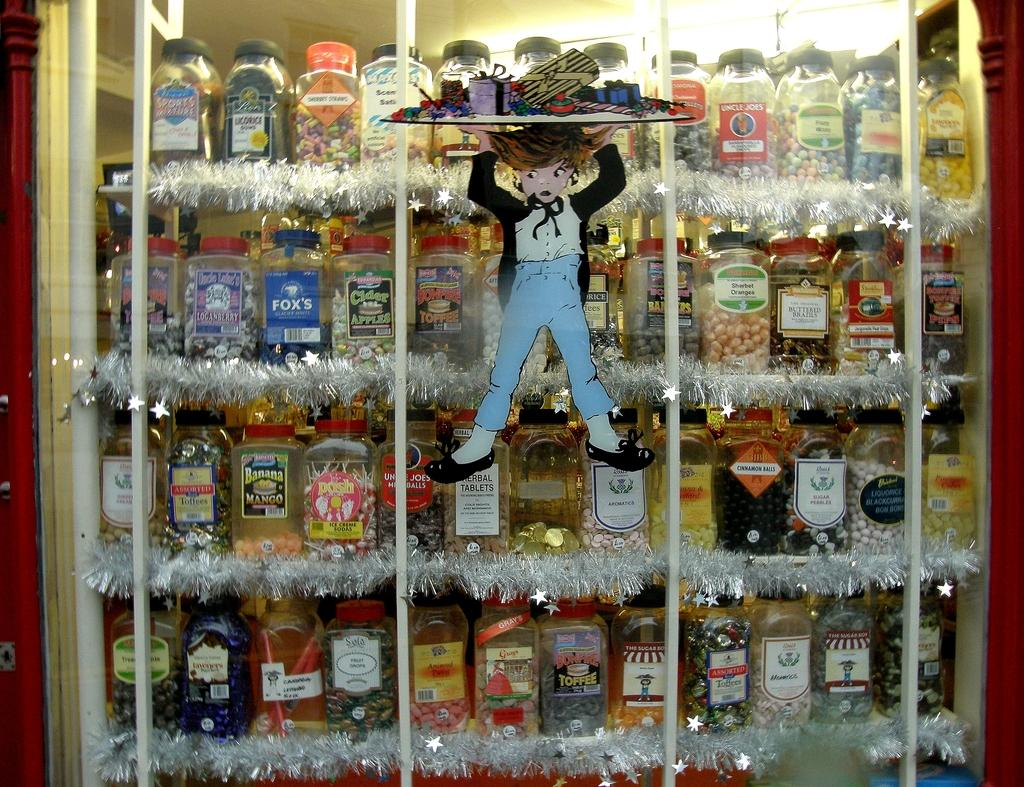Provide a one-sentence caption for the provided image. I store front display of many types of booze like Banana Mango. 